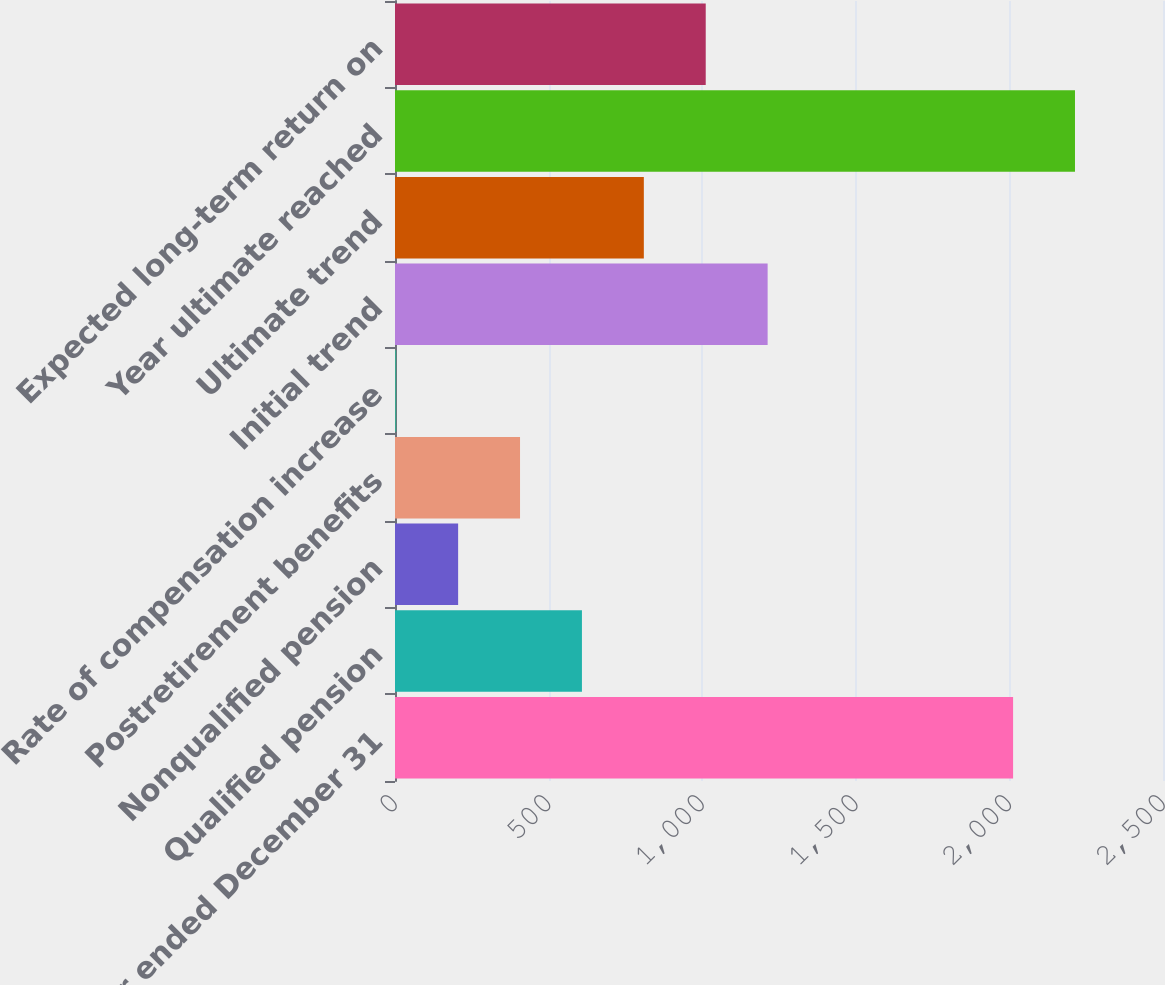Convert chart to OTSL. <chart><loc_0><loc_0><loc_500><loc_500><bar_chart><fcel>Year ended December 31<fcel>Qualified pension<fcel>Nonqualified pension<fcel>Postretirement benefits<fcel>Rate of compensation increase<fcel>Initial trend<fcel>Ultimate trend<fcel>Year ultimate reached<fcel>Expected long-term return on<nl><fcel>2012<fcel>608.5<fcel>205.5<fcel>407<fcel>4<fcel>1213<fcel>810<fcel>2213.5<fcel>1011.5<nl></chart> 